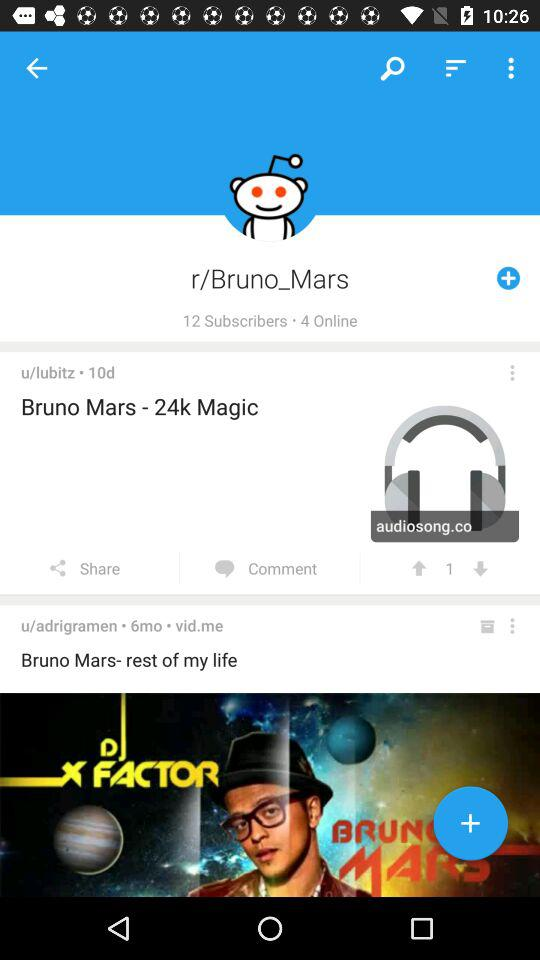What is the username? The usernames are "u/lubitz" and "u/adrigramen". 